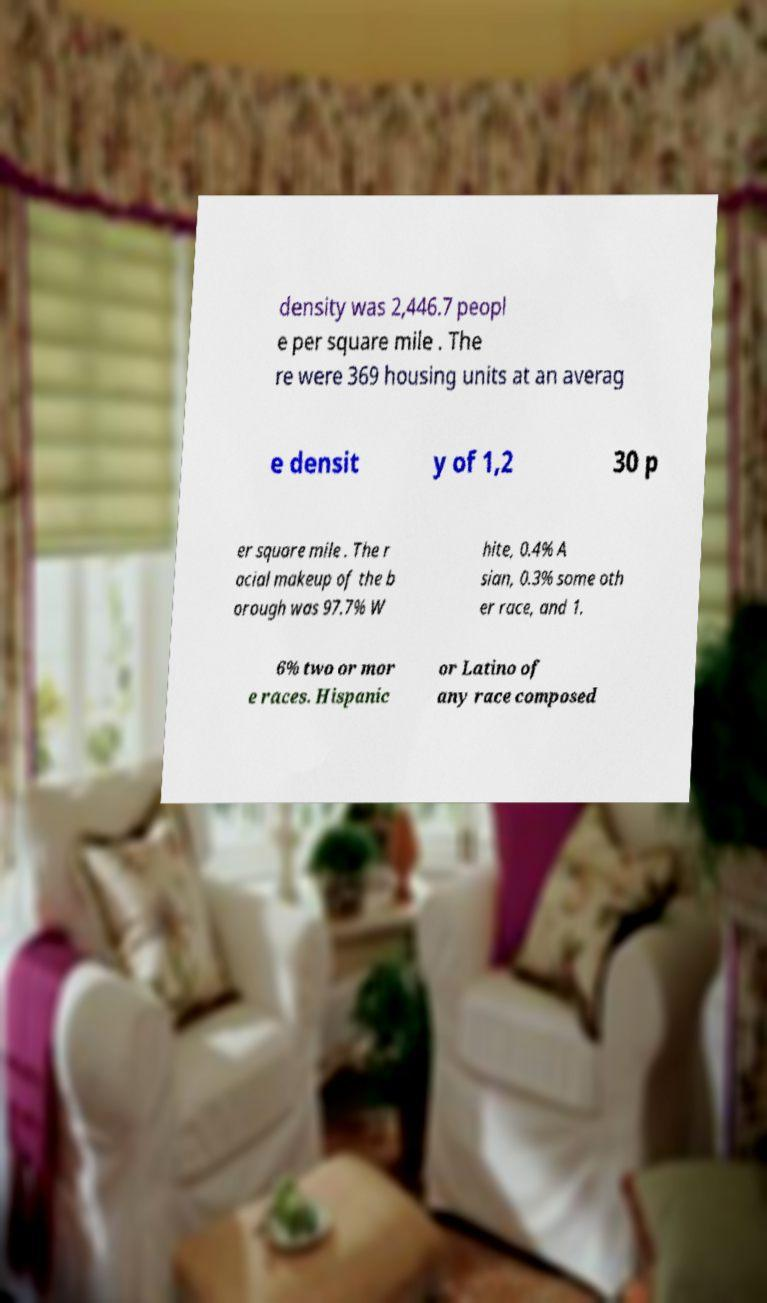What messages or text are displayed in this image? I need them in a readable, typed format. density was 2,446.7 peopl e per square mile . The re were 369 housing units at an averag e densit y of 1,2 30 p er square mile . The r acial makeup of the b orough was 97.7% W hite, 0.4% A sian, 0.3% some oth er race, and 1. 6% two or mor e races. Hispanic or Latino of any race composed 